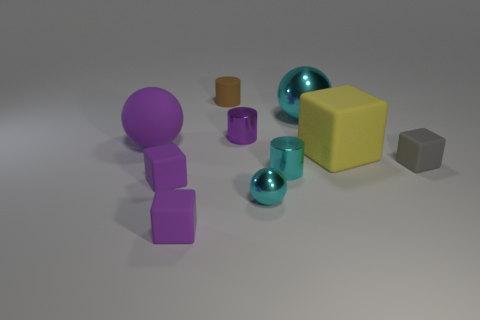Subtract 1 blocks. How many blocks are left? 3 Subtract all yellow cubes. How many cubes are left? 3 Subtract all cyan blocks. Subtract all yellow balls. How many blocks are left? 4 Subtract all spheres. How many objects are left? 7 Subtract 0 green blocks. How many objects are left? 10 Subtract all big cubes. Subtract all cyan metal things. How many objects are left? 6 Add 2 tiny metallic balls. How many tiny metallic balls are left? 3 Add 6 cyan spheres. How many cyan spheres exist? 8 